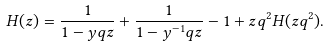Convert formula to latex. <formula><loc_0><loc_0><loc_500><loc_500>H ( z ) = \frac { 1 } { 1 - y q z } + \frac { 1 } { 1 - y ^ { - 1 } q z } - 1 + z q ^ { 2 } H ( z q ^ { 2 } ) .</formula> 